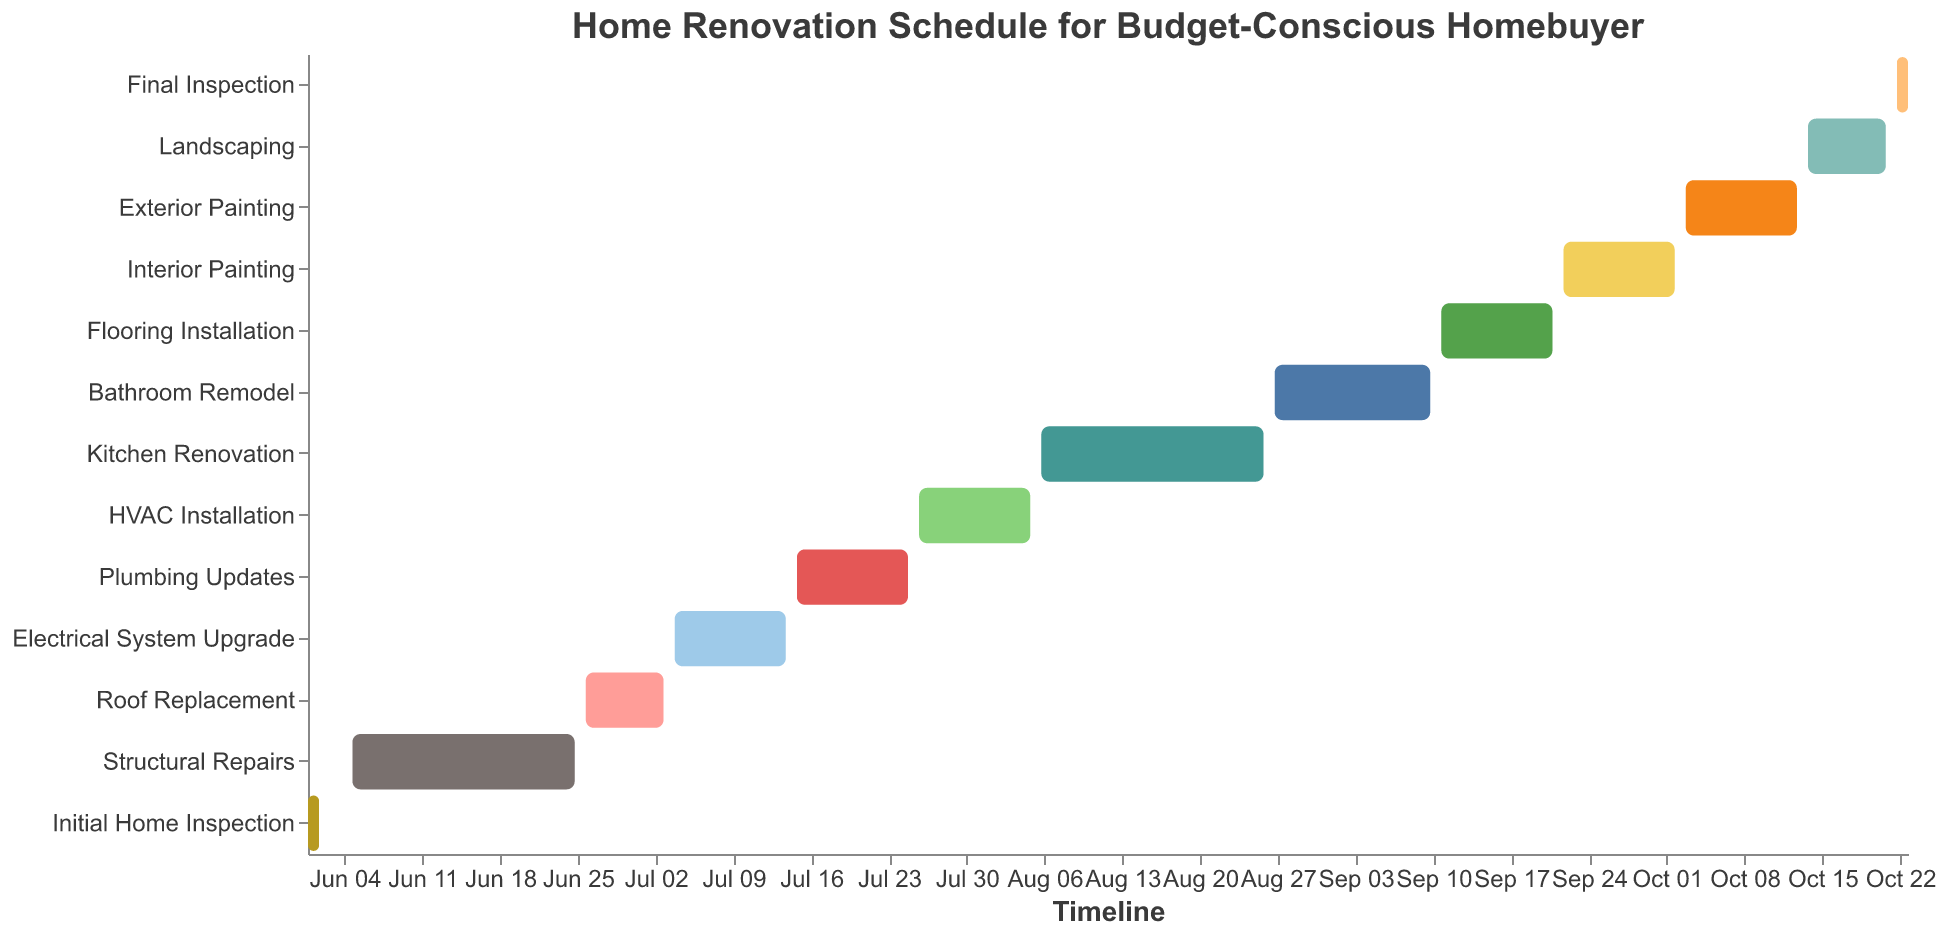What's the title of the chart? The title is usually at the top of the chart and summarizes the main topic or purpose of the chart. In this case, it reads "Home Renovation Schedule for Budget-Conscious Homebuyer".
Answer: Home Renovation Schedule for Budget-Conscious Homebuyer How many tasks are listed in the renovation schedule? Count the unique tasks listed along the y-axis of the chart. Each task corresponds to one row.
Answer: 13 Which task has the longest duration? Observe the length of the bars for each task and check the tooltip or the "Duration (days)" field to identify the task with the maximum duration.
Answer: Structural Repairs What is the duration of the "Kitchen Renovation"? Look for the "Kitchen Renovation" task on the y-axis and refer to the tooltip or bar's associated duration.
Answer: 21 days When does the "Roof Replacement" task start and end? Locate the "Roof Replacement" task on the y-axis, and check the start and end date from the bar or tooltip.
Answer: Starts on June 26, 2023, and ends on July 3, 2023 What is the total duration of all painting tasks combined? Identify all painting-related tasks (Interior and Exterior Painting), sum their durations. Interior Painting is 11 days and Exterior Painting is 11 days.
Answer: 22 days Are there any tasks that have the same duration? Compare the duration of each task to see if there are any matches. Plumbing Updates, HVAC Installation, Flooring Installation, Interior Painting, and Exterior Painting all have 11-day durations.
Answer: Yes, there are multiple tasks with 11 days duration Which task overlaps with the "HVAC Installation"? Check the chronological order on the x-axis and see which tasks' timelines coincide with the "HVAC Installation" (July 26, 2023, to August 5, 2023).
Answer: Kitchen Renovation Which task is the last one on the renovation schedule? Look at the y-axis to find the task that is listed at the bottom, indicating the final task chronologically.
Answer: Final Inspection How many tasks have durations longer than two weeks? Calculate 14 days as the threshold and count the number of tasks with durations exceeding this.
Answer: 3 tasks (Structural Repairs, Kitchen Renovation, Bathroom Remodel) 